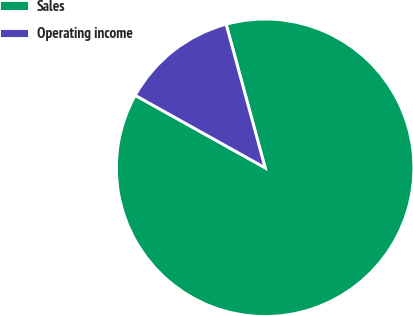Convert chart. <chart><loc_0><loc_0><loc_500><loc_500><pie_chart><fcel>Sales<fcel>Operating income<nl><fcel>87.32%<fcel>12.68%<nl></chart> 